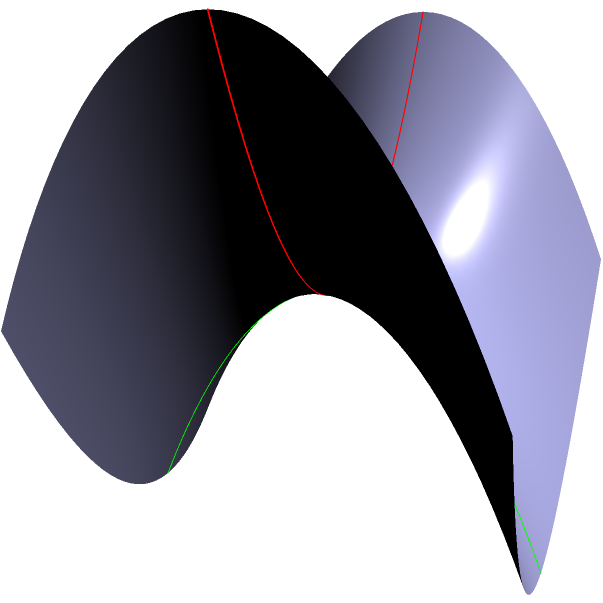In the context of non-Euclidean geometry on a saddle-shaped surface, which of the following statements about geodesics is most accurate? Consider how this concept might be metaphorically applied to character arcs in classic films.

a) Geodesics on a saddle surface always intersect at right angles.
b) Parallel geodesics on a saddle surface can diverge.
c) All geodesics on a saddle surface are closed curves.
d) Geodesics on a saddle surface always follow the lines of steepest descent. Let's approach this step-by-step:

1) A saddle surface is a hyperbolic paraboloid, represented by the equation $z = x^2 - y^2$ in the graph.

2) Geodesics on a surface are the curves that locally minimize distance between points on that surface. They are the equivalent of straight lines on a plane.

3) On a saddle surface:
   a) Geodesics don't always intersect at right angles. This is a property of Euclidean geometry, not hyperbolic geometry.
   b) Parallel geodesics can indeed diverge. This is a key feature of hyperbolic geometry.
   c) Not all geodesics are closed curves. Many are open and extend infinitely.
   d) Geodesics don't always follow the lines of steepest descent. They can curve in various ways.

4) The correct answer is b) Parallel geodesics on a saddle surface can diverge.

5) Metaphorically, in classic films, character arcs that start similarly (parallel) can diverge dramatically due to the "curvature" of the plot, much like geodesics on a saddle surface.

For example, in "Casablanca" (1942), Rick and Ilsa's paths initially run parallel but dramatically diverge due to the "curvature" of wartime circumstances, exemplifying this geodesic-like behavior in narrative structure.
Answer: b) Parallel geodesics on a saddle surface can diverge. 